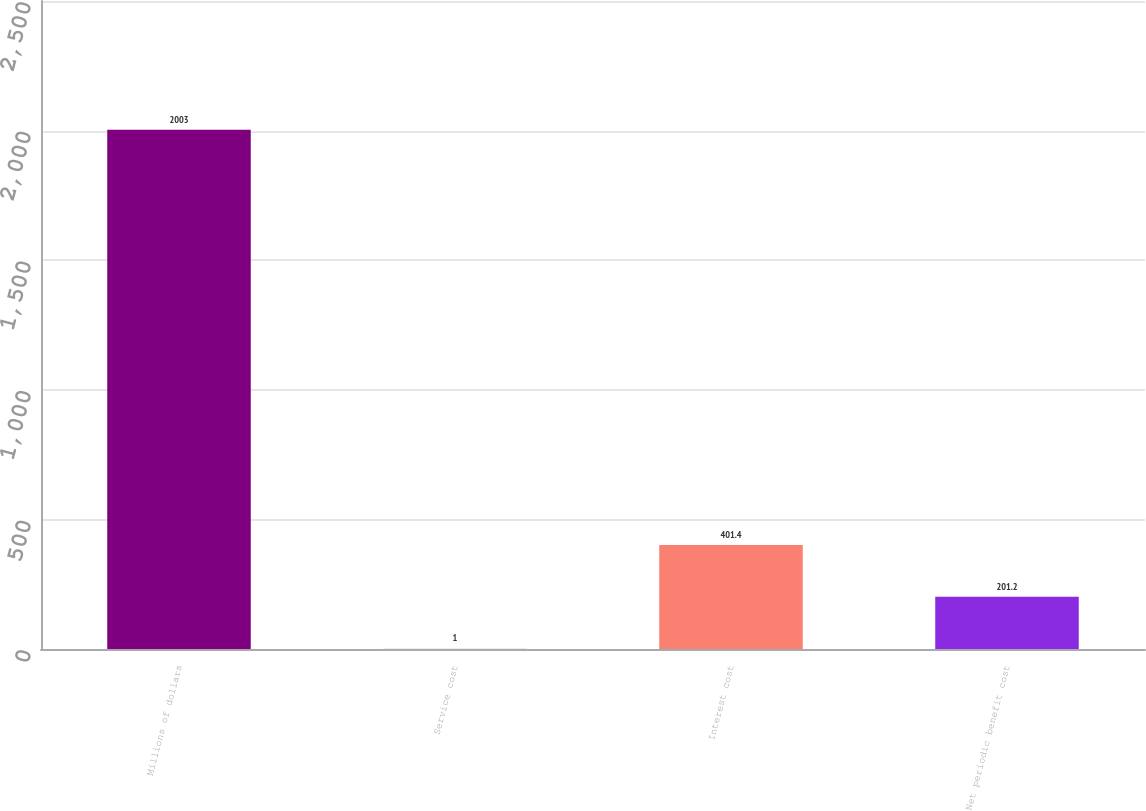Convert chart. <chart><loc_0><loc_0><loc_500><loc_500><bar_chart><fcel>Millions of dollars<fcel>Service cost<fcel>Interest cost<fcel>Net periodic benefit cost<nl><fcel>2003<fcel>1<fcel>401.4<fcel>201.2<nl></chart> 